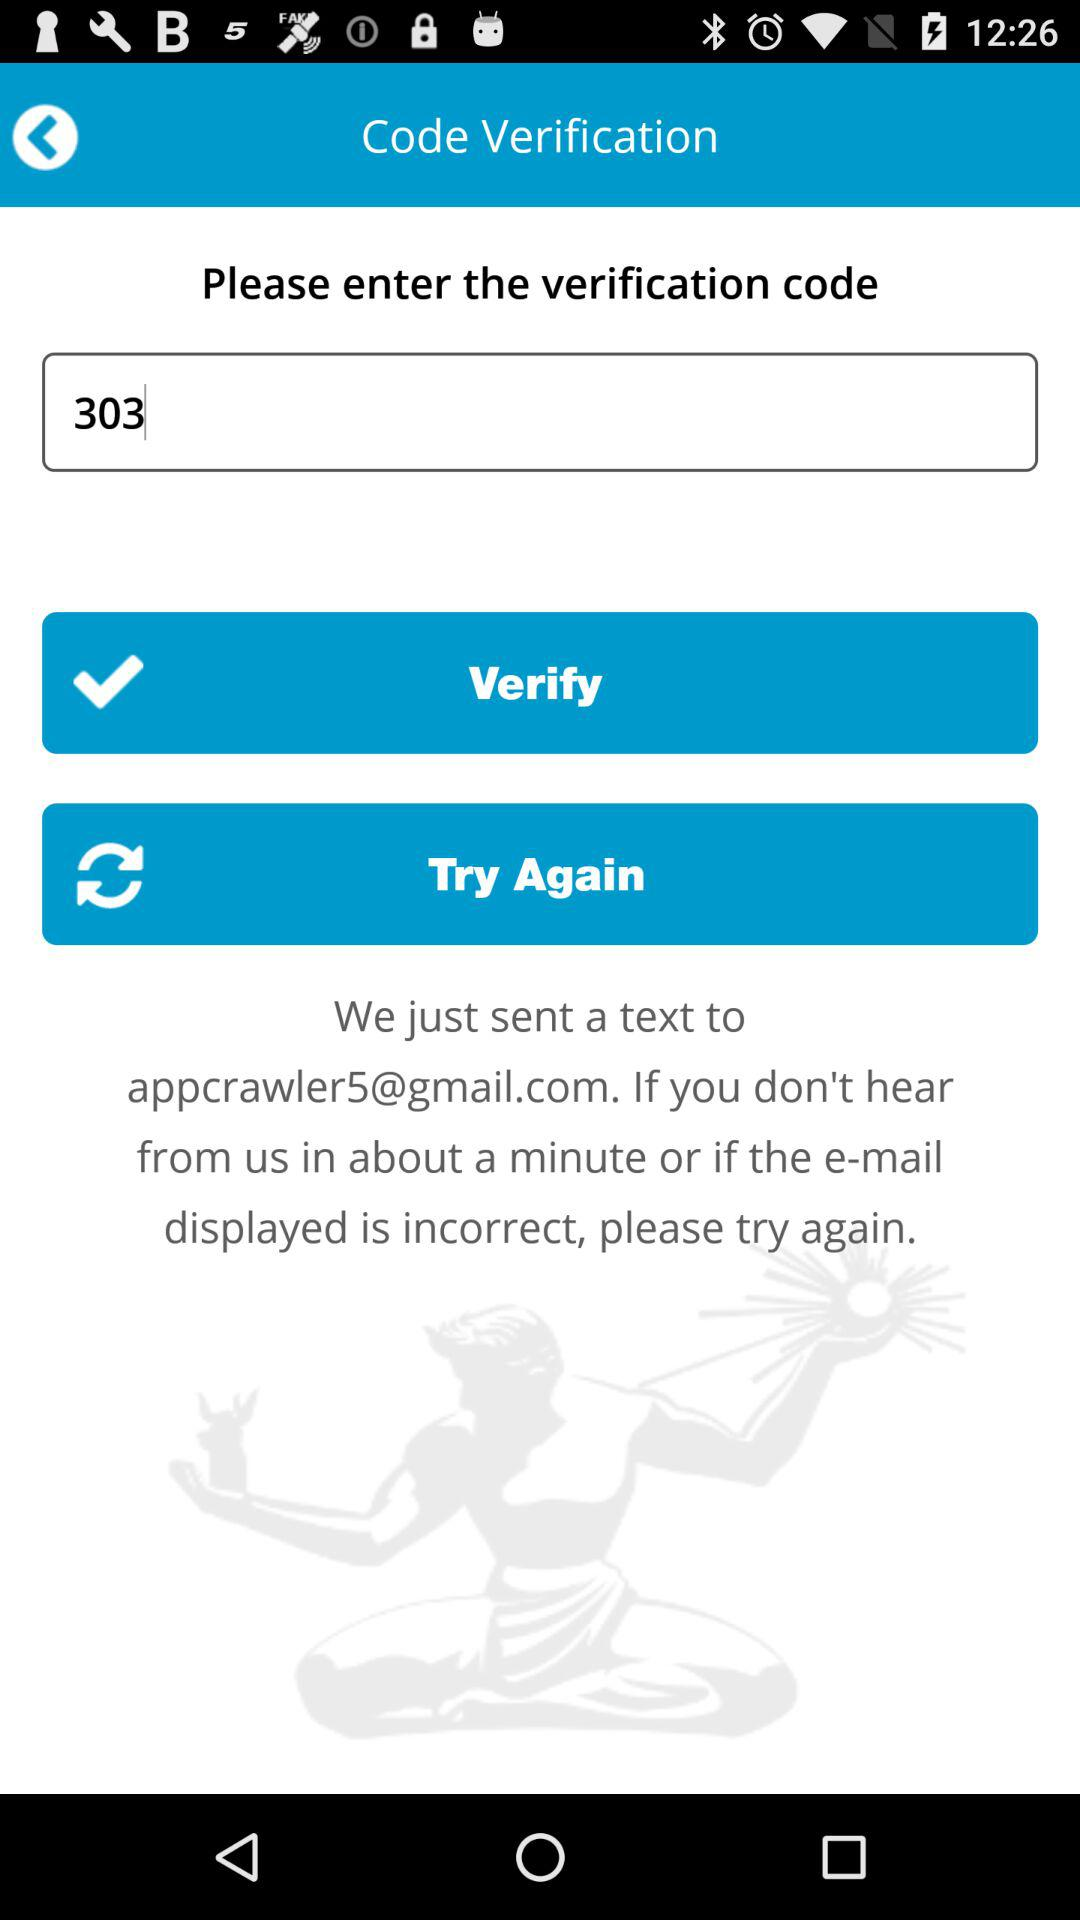What is the email address? The email address is appcrawler5@gmail.com. 